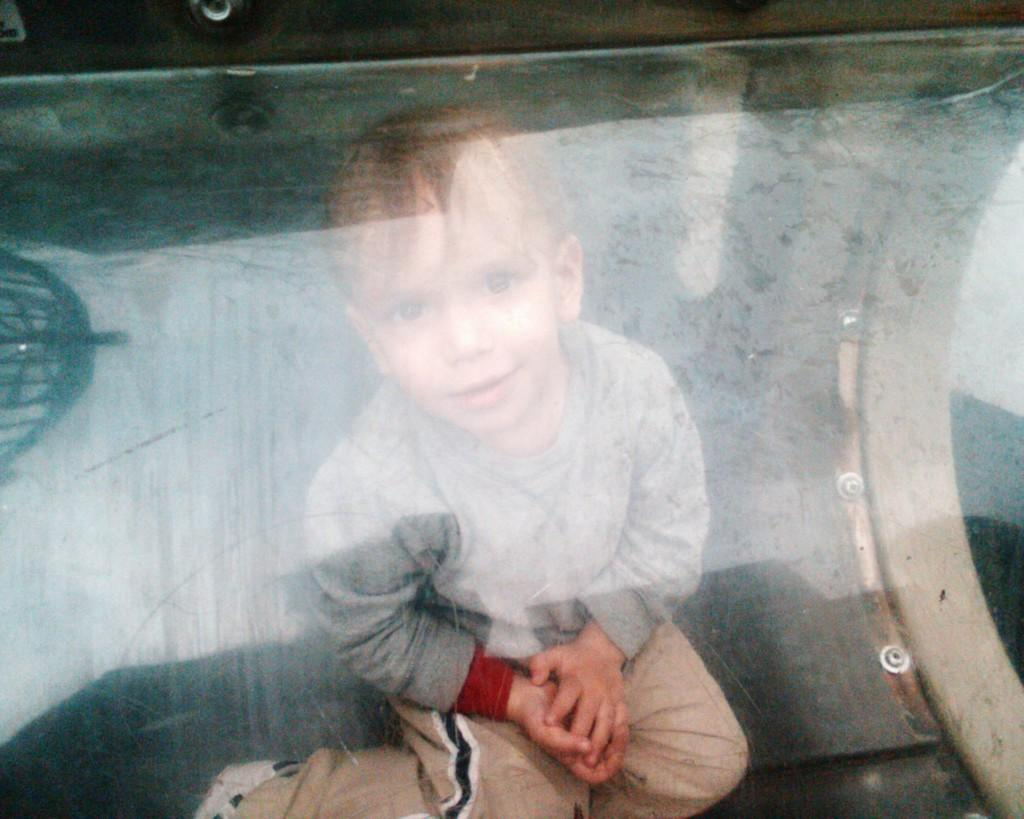What is the main subject of the image? There is a boy in the image. What is the boy doing in the image? The boy is sitting. What type of pail is the boy using to scrub his skin in the image? There is no pail or skin-scrubbing activity present in the image. What type of cork is the boy holding in the image? There is no cork present in the image. 